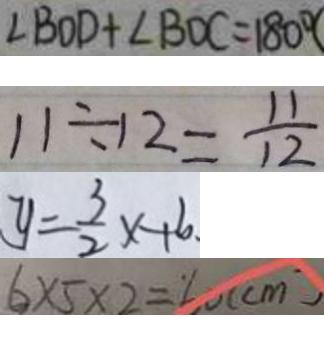Convert formula to latex. <formula><loc_0><loc_0><loc_500><loc_500>\angle B O D + \angle B D C = 1 8 0 ^ { \circ } 
 1 1 \div 1 2 = \frac { 1 1 } { 1 2 } 
 y = \frac { 3 } { 2 } x + 6 . 
 6 \times 5 \times 2 = 6 0 ( c m )</formula> 